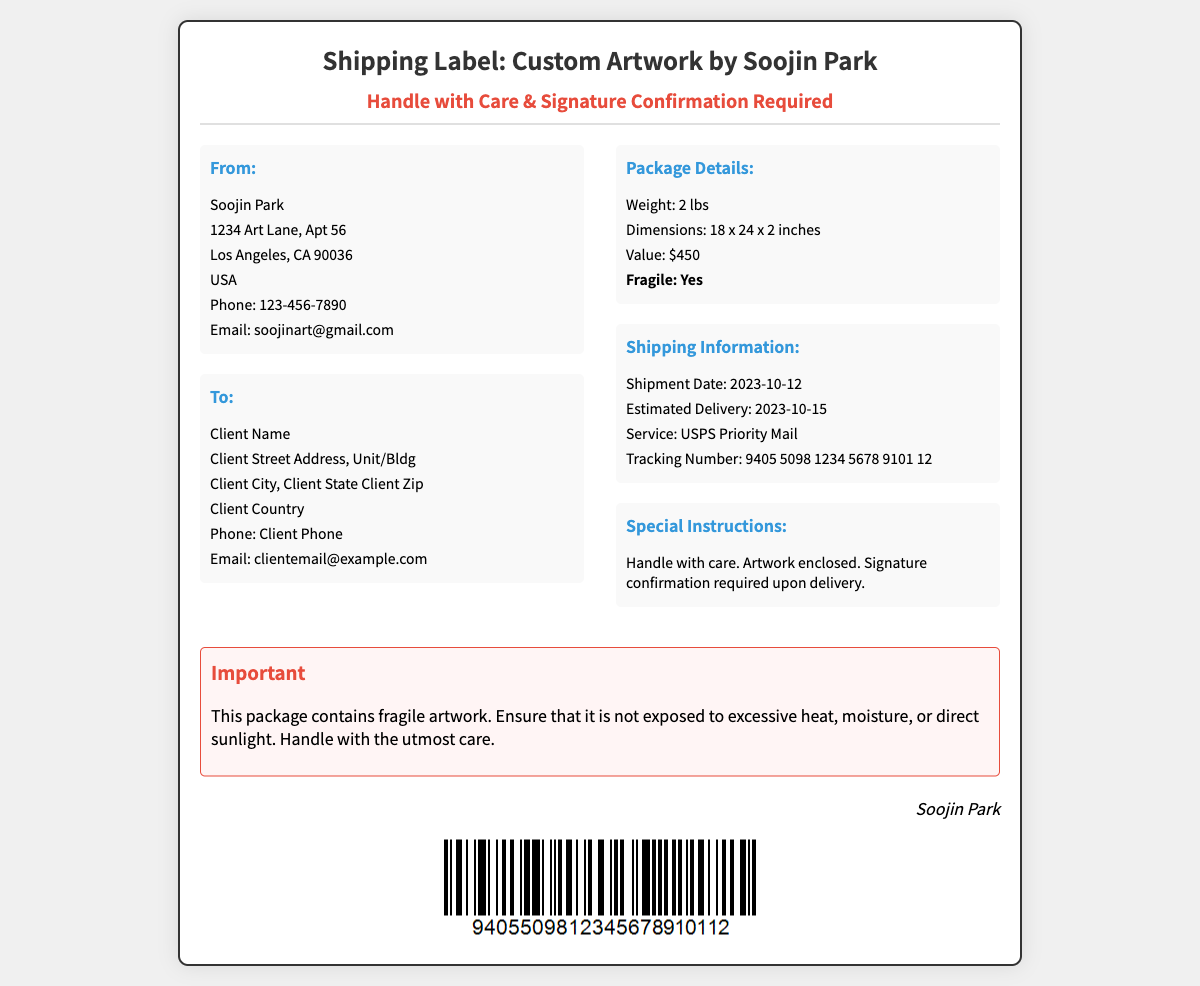What is the sender's name? The sender's name is found in the "From" section of the label.
Answer: Soojin Park What city is the sender located in? The sender's address indicates their city in the "From" section.
Answer: Los Angeles What is the estimated delivery date? The estimated delivery date is provided in the "Shipping Information" section.
Answer: 2023-10-15 What is the weight of the package? The weight is specified in the "Package Details" section of the label.
Answer: 2 lbs What is the value of the artwork? The value is mentioned in the "Package Details" section.
Answer: $450 What special instructions accompany the package? The special instructions are detailed in the "Special Instructions" section.
Answer: Handle with care. Artwork enclosed. Signature confirmation required upon delivery What services are used for shipping? The shipping service is listed in the "Shipping Information" section.
Answer: USPS Priority Mail Why is signature confirmation required? The reason is inferred from the context of handling valuable artwork.
Answer: To ensure safe delivery What warning is provided about the package? The warning is noted in the "Important" section of the label.
Answer: This package contains fragile artwork 